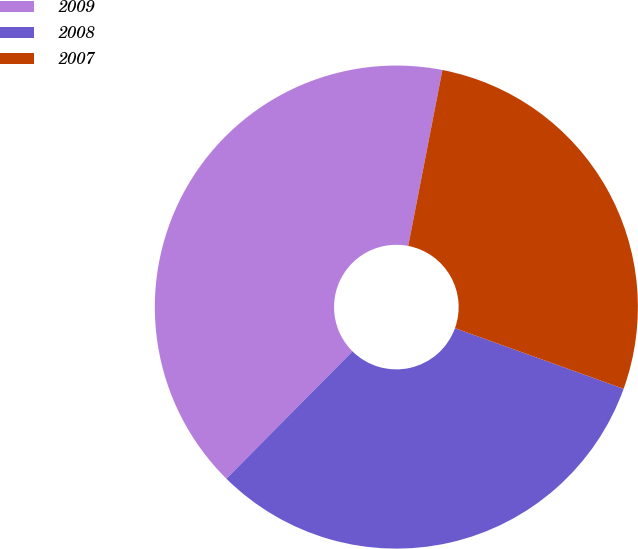<chart> <loc_0><loc_0><loc_500><loc_500><pie_chart><fcel>2009<fcel>2008<fcel>2007<nl><fcel>40.63%<fcel>31.93%<fcel>27.44%<nl></chart> 